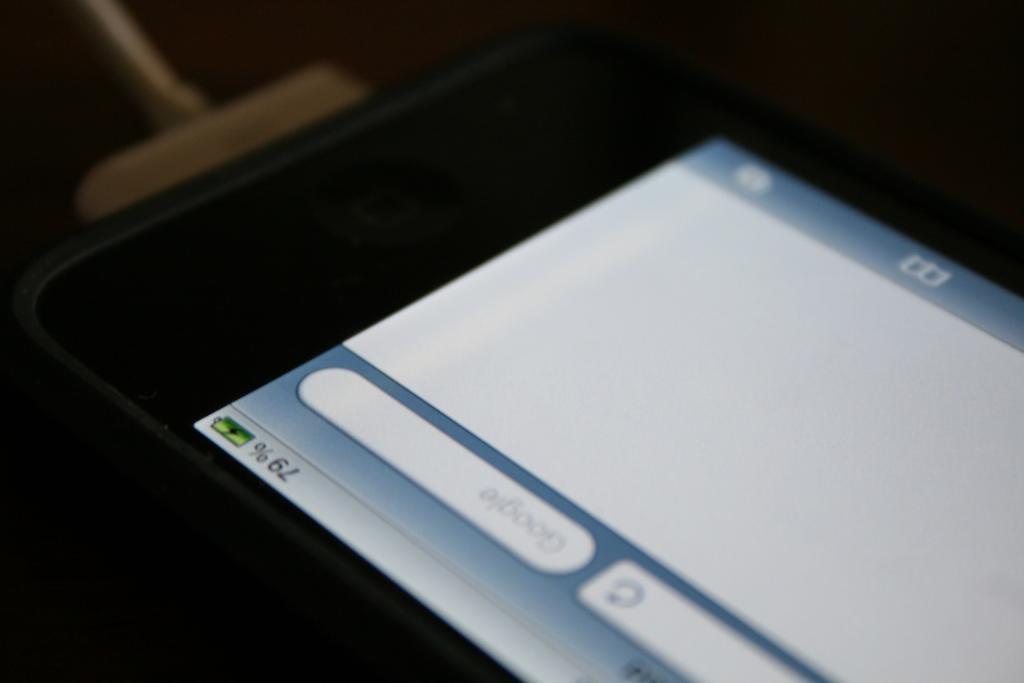What percent of battery is left ?
Keep it short and to the point. 79. How much battery is left?
Your answer should be compact. 79%. 